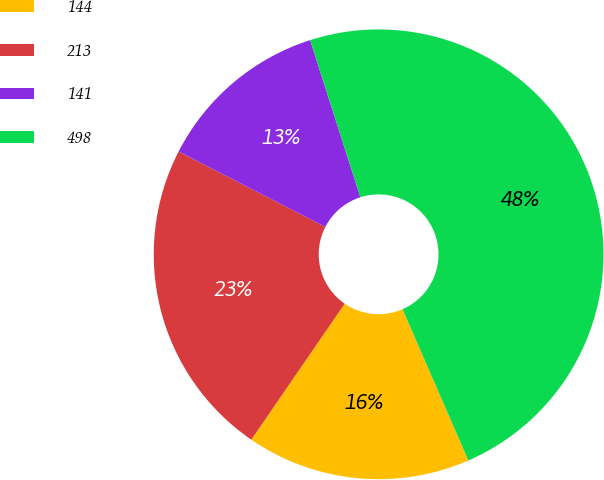<chart> <loc_0><loc_0><loc_500><loc_500><pie_chart><fcel>144<fcel>213<fcel>141<fcel>498<nl><fcel>16.11%<fcel>22.98%<fcel>12.52%<fcel>48.39%<nl></chart> 